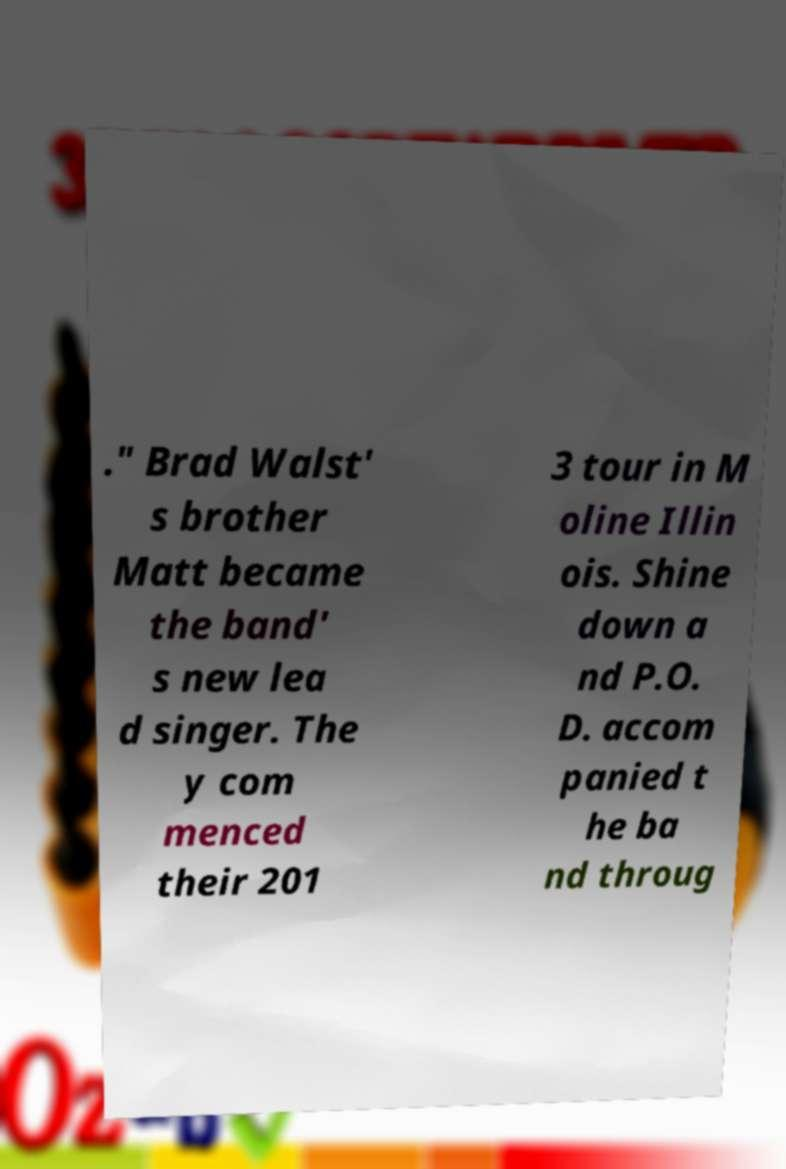Can you accurately transcribe the text from the provided image for me? ." Brad Walst' s brother Matt became the band' s new lea d singer. The y com menced their 201 3 tour in M oline Illin ois. Shine down a nd P.O. D. accom panied t he ba nd throug 